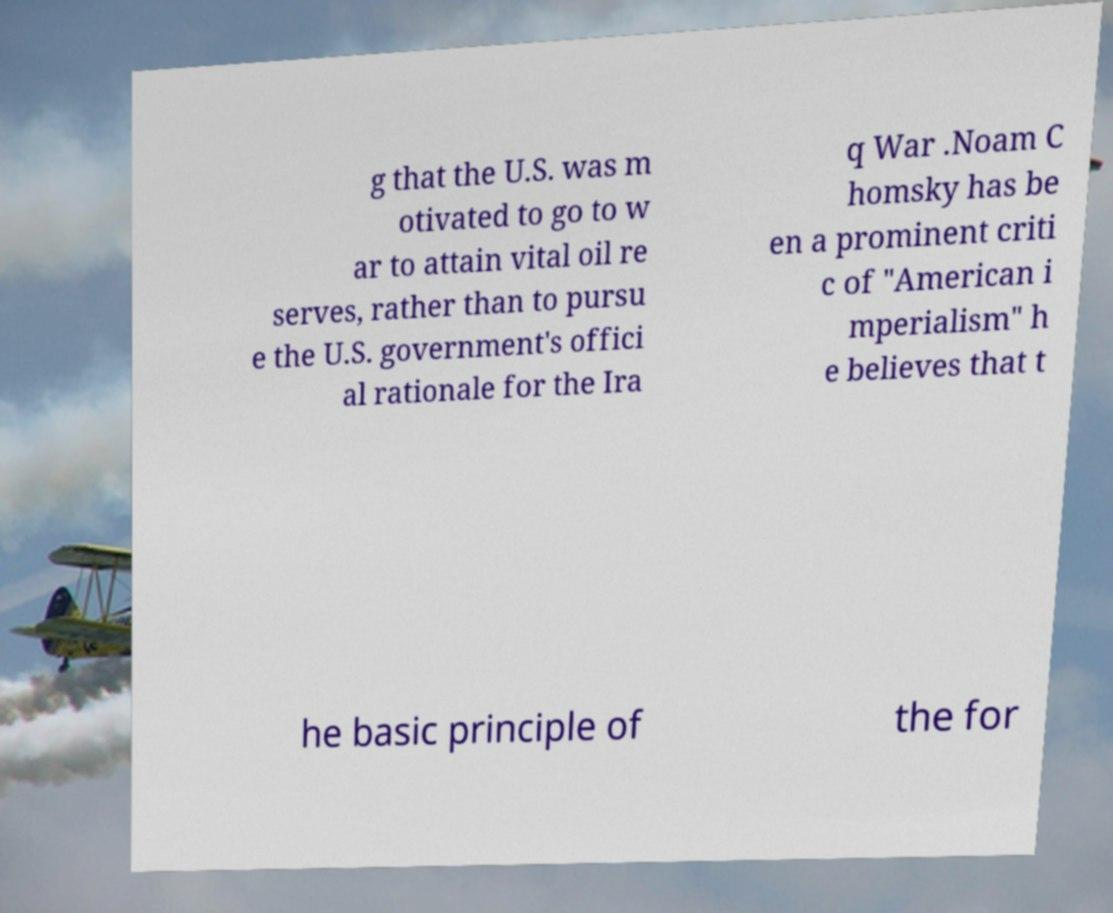Please read and relay the text visible in this image. What does it say? g that the U.S. was m otivated to go to w ar to attain vital oil re serves, rather than to pursu e the U.S. government's offici al rationale for the Ira q War .Noam C homsky has be en a prominent criti c of "American i mperialism" h e believes that t he basic principle of the for 